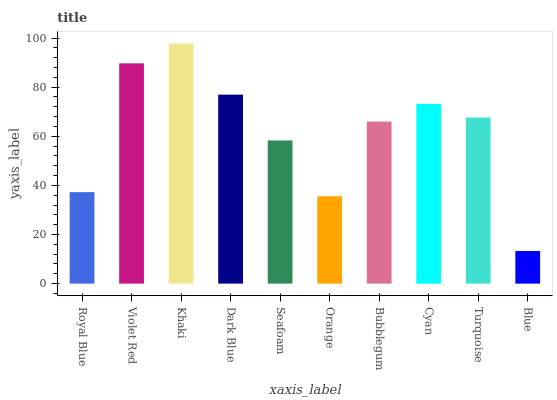Is Blue the minimum?
Answer yes or no. Yes. Is Khaki the maximum?
Answer yes or no. Yes. Is Violet Red the minimum?
Answer yes or no. No. Is Violet Red the maximum?
Answer yes or no. No. Is Violet Red greater than Royal Blue?
Answer yes or no. Yes. Is Royal Blue less than Violet Red?
Answer yes or no. Yes. Is Royal Blue greater than Violet Red?
Answer yes or no. No. Is Violet Red less than Royal Blue?
Answer yes or no. No. Is Turquoise the high median?
Answer yes or no. Yes. Is Bubblegum the low median?
Answer yes or no. Yes. Is Bubblegum the high median?
Answer yes or no. No. Is Dark Blue the low median?
Answer yes or no. No. 